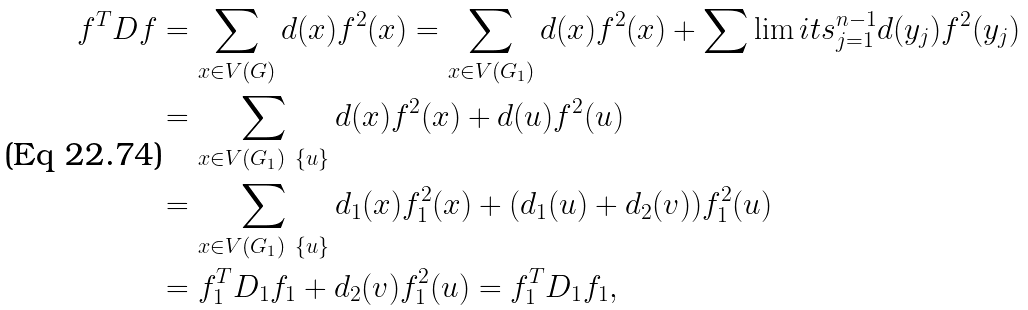Convert formula to latex. <formula><loc_0><loc_0><loc_500><loc_500>f ^ { T } D f & = \sum _ { x \in V ( G ) } d ( x ) f ^ { 2 } ( x ) = \sum _ { x \in V ( G _ { 1 } ) } d ( x ) f ^ { 2 } ( x ) + \sum \lim i t s _ { j = 1 } ^ { n - 1 } d ( y _ { j } ) f ^ { 2 } ( y _ { j } ) \\ & = \sum _ { x \in V ( G _ { 1 } ) \ \{ u \} } d ( x ) f ^ { 2 } ( x ) + d ( u ) f ^ { 2 } ( u ) \\ & = \sum _ { x \in V ( G _ { 1 } ) \ \{ u \} } d _ { 1 } ( x ) f ^ { 2 } _ { 1 } ( x ) + ( d _ { 1 } ( u ) + d _ { 2 } ( v ) ) f ^ { 2 } _ { 1 } ( u ) \\ & = f _ { 1 } ^ { T } D _ { 1 } f _ { 1 } + d _ { 2 } ( v ) f ^ { 2 } _ { 1 } ( u ) = f _ { 1 } ^ { T } D _ { 1 } f _ { 1 } ,</formula> 